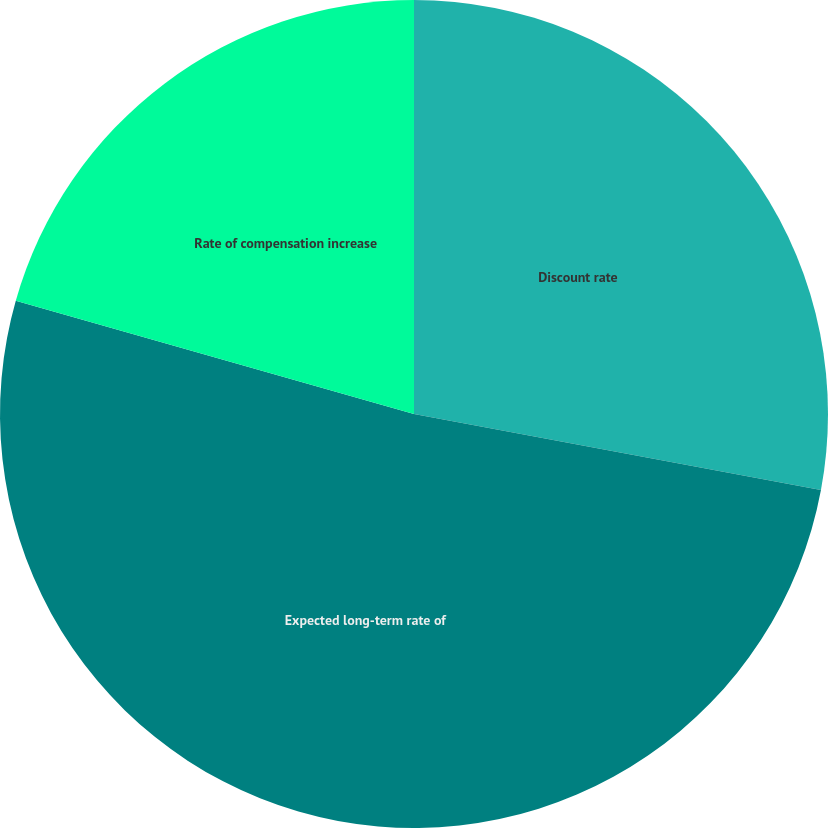Convert chart. <chart><loc_0><loc_0><loc_500><loc_500><pie_chart><fcel>Discount rate<fcel>Expected long-term rate of<fcel>Rate of compensation increase<nl><fcel>27.94%<fcel>51.47%<fcel>20.59%<nl></chart> 